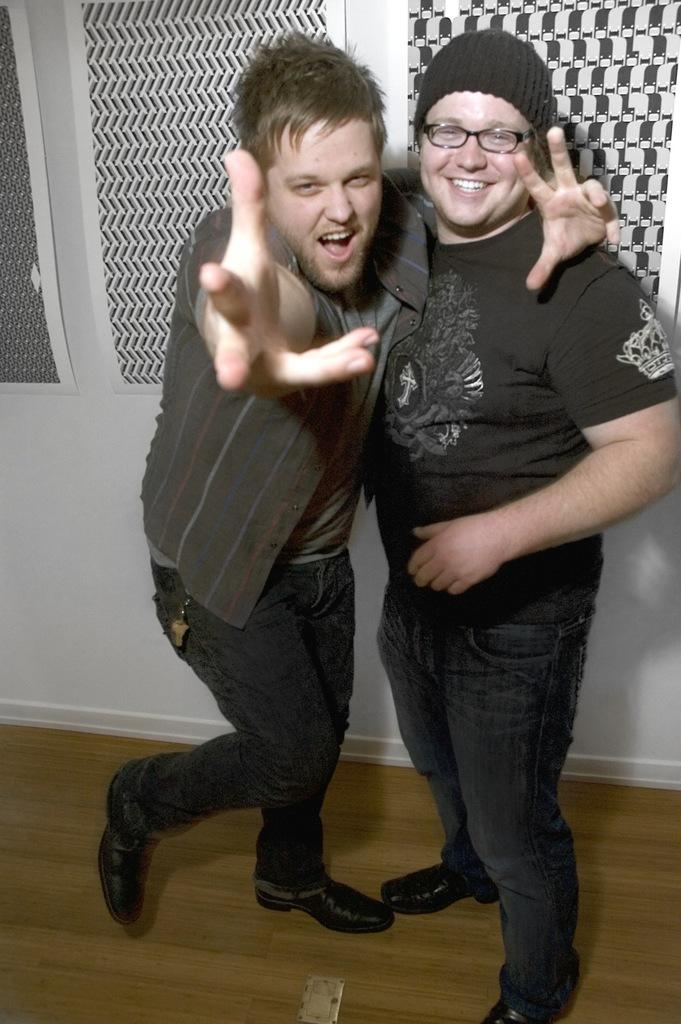How many people are present in the image? There are two people standing in the image. What can be seen behind the people in the image? There is a white color wall in the image. What decorative elements are present in the image? There are banners in the image. What type of property is being sold in the image? There is no indication in the image that a property is being sold. What rail is visible in the image? There is no rail present in the image. What self-help book is the person holding in the image? There is no self-help book visible in the image. 